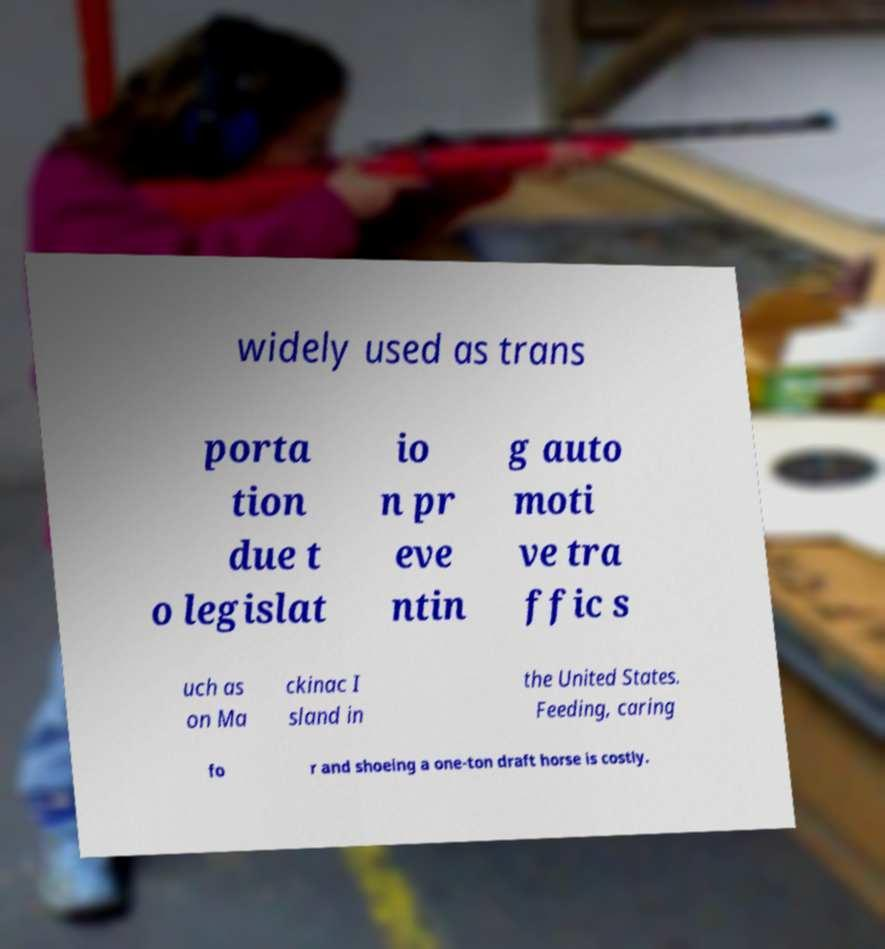Can you accurately transcribe the text from the provided image for me? widely used as trans porta tion due t o legislat io n pr eve ntin g auto moti ve tra ffic s uch as on Ma ckinac I sland in the United States. Feeding, caring fo r and shoeing a one-ton draft horse is costly. 